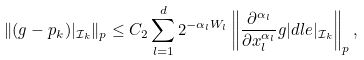Convert formula to latex. <formula><loc_0><loc_0><loc_500><loc_500>\| ( g - p _ { k } ) | _ { \mathcal { I } _ { k } } \| _ { p } \leq C _ { 2 } \sum _ { l = 1 } ^ { d } 2 ^ { - \alpha _ { l } W _ { l } } \left \| \frac { \partial ^ { \alpha _ { l } } } { \partial x _ { l } ^ { \alpha _ { l } } } g | d l e | _ { \mathcal { I } _ { k } } \right \| _ { p } ,</formula> 